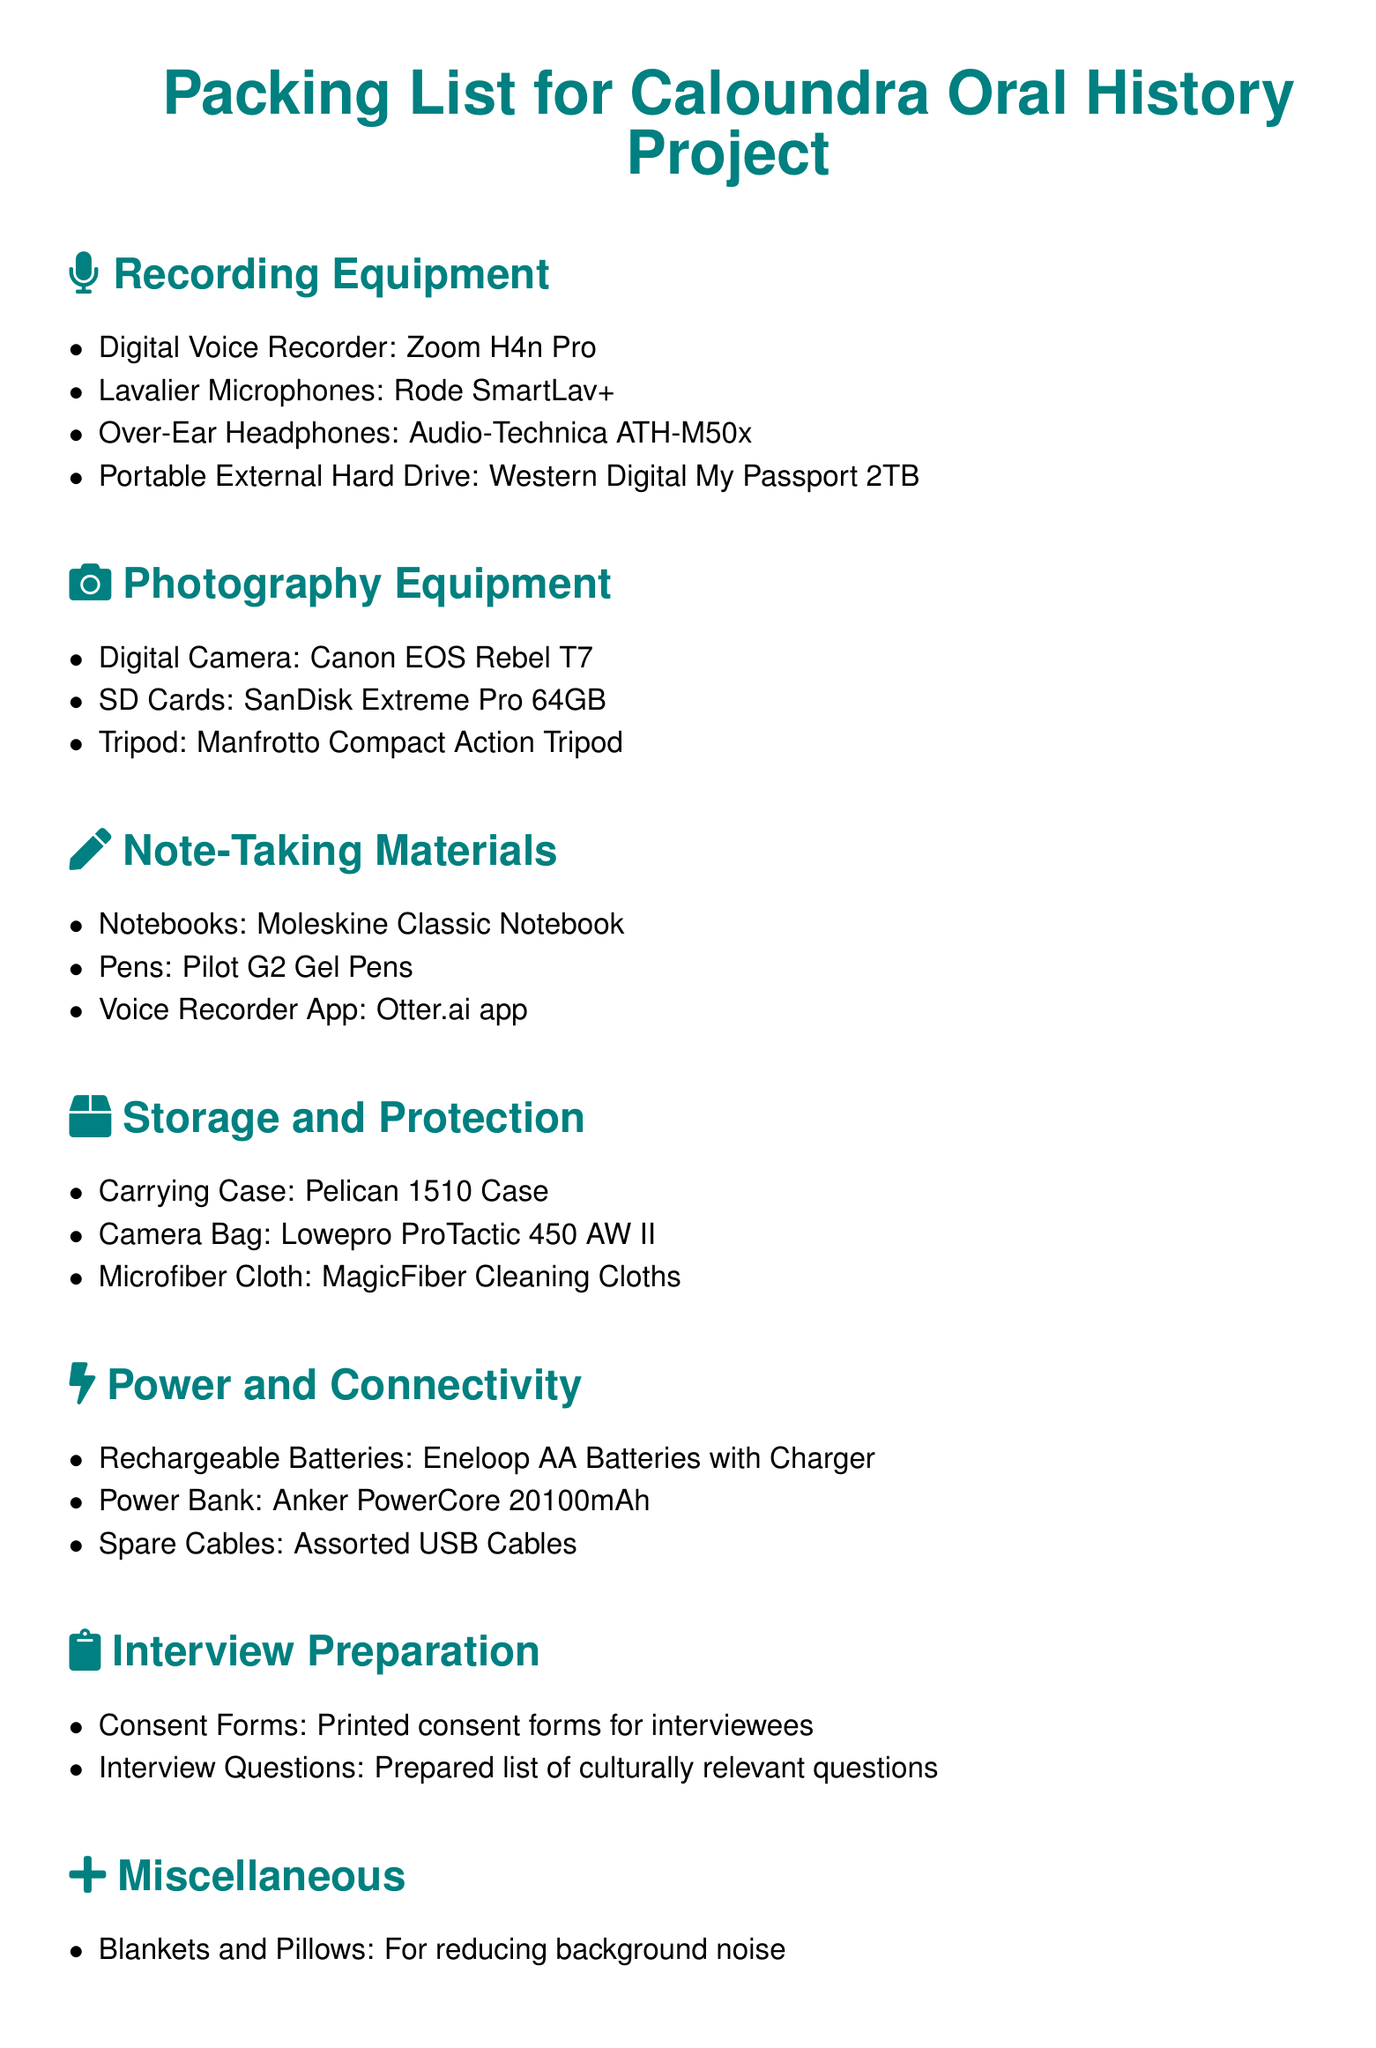What digital voice recorder is listed? The digital voice recorder mentioned in the document is the Zoom H4n Pro.
Answer: Zoom H4n Pro How many SD cards are mentioned in the photography equipment section? The document lists one type of SD card, which is SanDisk Extreme Pro 64GB.
Answer: SanDisk Extreme Pro 64GB What is the purpose of the blankets and pillows? The blankets and pillows are intended for reducing background noise during interviews.
Answer: Reducing background noise Which power bank is recommended in the packing list? The recommended power bank in the packing list is Anker PowerCore 20100mAh.
Answer: Anker PowerCore 20100mAh What is the total number of items listed under recording equipment? There are four items listed under recording equipment: Digital Voice Recorder, Lavalier Microphones, Over-Ear Headphones, and Portable External Hard Drive.
Answer: Four items What is included in the interview preparation category? The interview preparation category includes consent forms and a prepared list of culturally relevant questions.
Answer: Consent forms and interview questions Which notebook brand is mentioned in the note-taking materials? The document mentions Moleskine as the brand of notebook in the note-taking materials.
Answer: Moleskine What type of camera is suggested for photography? The suggested camera for photography in the document is Canon EOS Rebel T7.
Answer: Canon EOS Rebel T7 What kind of case is recommended for carrying equipment? The recommended carrying case is a Pelican 1510 Case in the packing list.
Answer: Pelican 1510 Case 